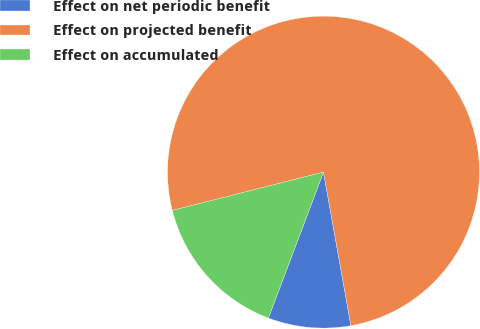Convert chart. <chart><loc_0><loc_0><loc_500><loc_500><pie_chart><fcel>Effect on net periodic benefit<fcel>Effect on projected benefit<fcel>Effect on accumulated<nl><fcel>8.56%<fcel>76.13%<fcel>15.31%<nl></chart> 